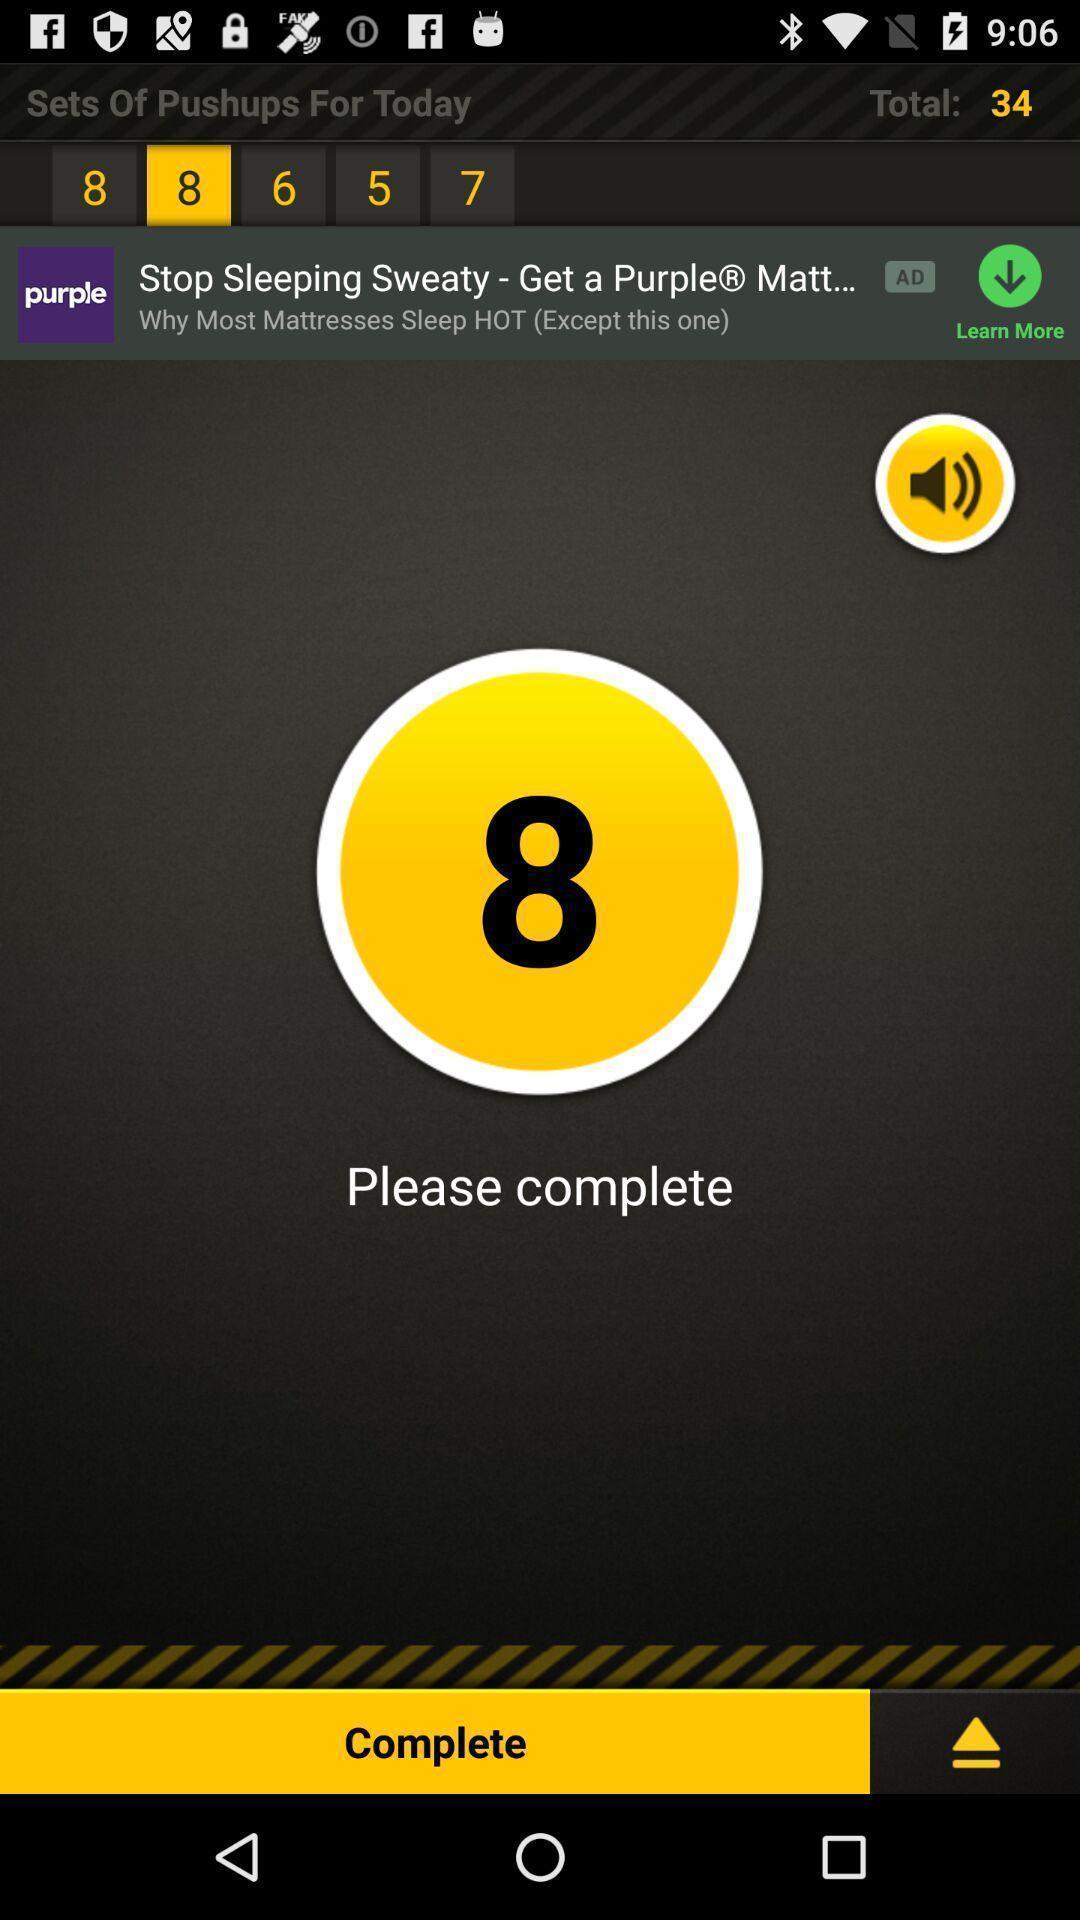Describe the content in this image. Page showing to complete push ups on app. 